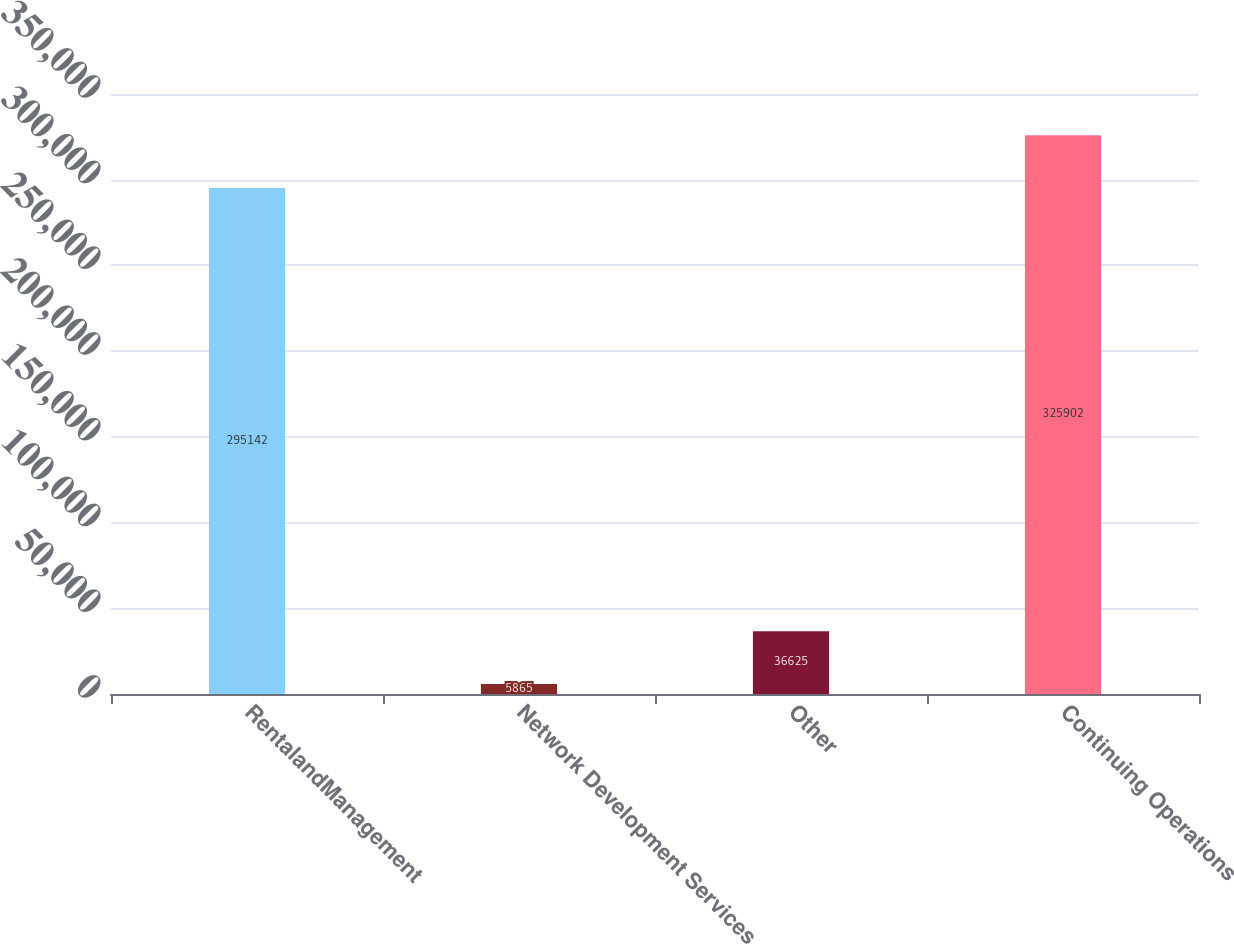Convert chart. <chart><loc_0><loc_0><loc_500><loc_500><bar_chart><fcel>RentalandManagement<fcel>Network Development Services<fcel>Other<fcel>Continuing Operations<nl><fcel>295142<fcel>5865<fcel>36625<fcel>325902<nl></chart> 